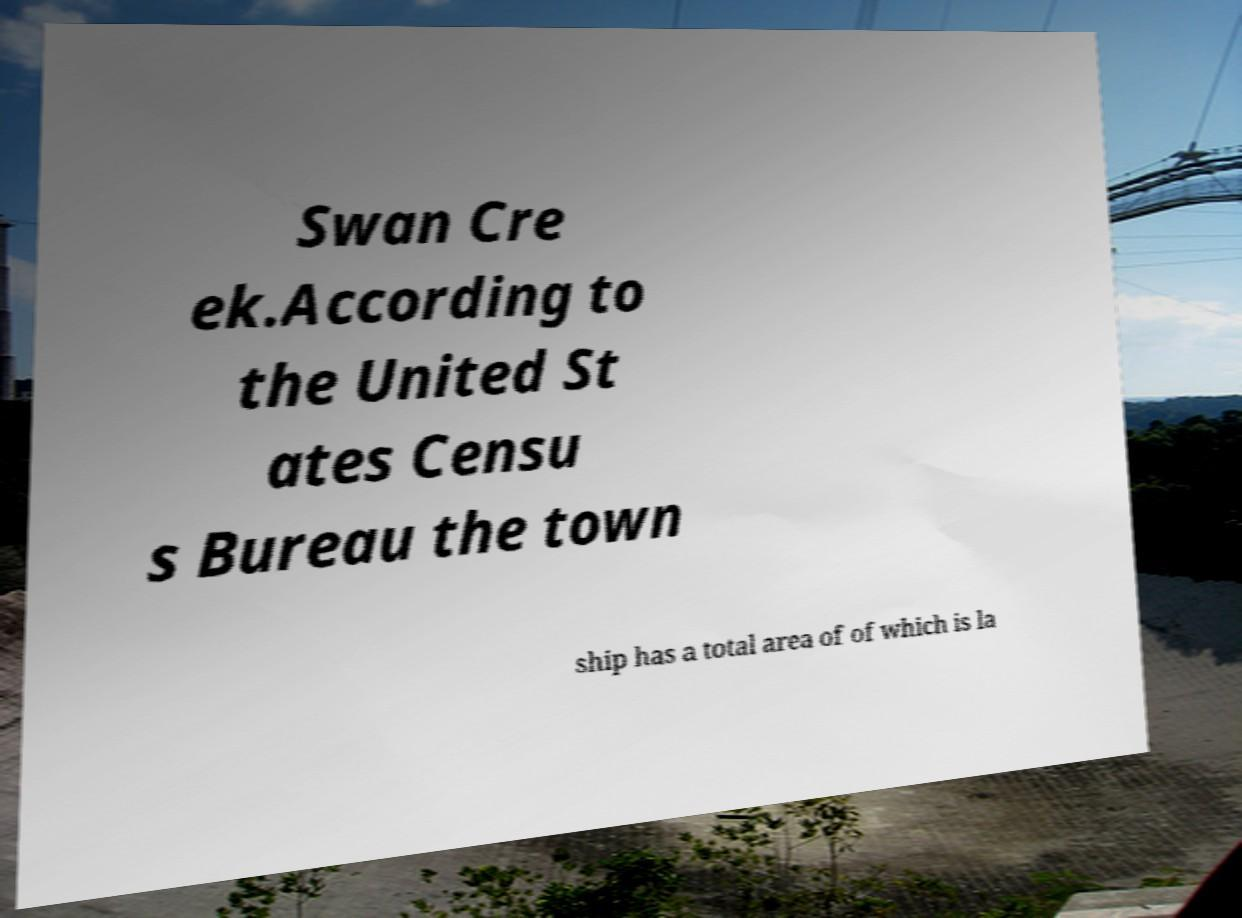Can you read and provide the text displayed in the image?This photo seems to have some interesting text. Can you extract and type it out for me? Swan Cre ek.According to the United St ates Censu s Bureau the town ship has a total area of of which is la 